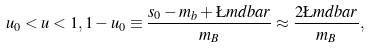Convert formula to latex. <formula><loc_0><loc_0><loc_500><loc_500>u _ { 0 } < u < 1 , 1 - u _ { 0 } \equiv \frac { s _ { 0 } - m _ { b } + \L m d b a r } { m _ { B } } \approx \frac { 2 \L m d b a r } { m _ { B } } ,</formula> 